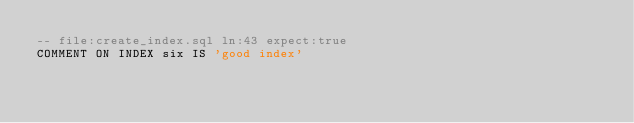<code> <loc_0><loc_0><loc_500><loc_500><_SQL_>-- file:create_index.sql ln:43 expect:true
COMMENT ON INDEX six IS 'good index'
</code> 